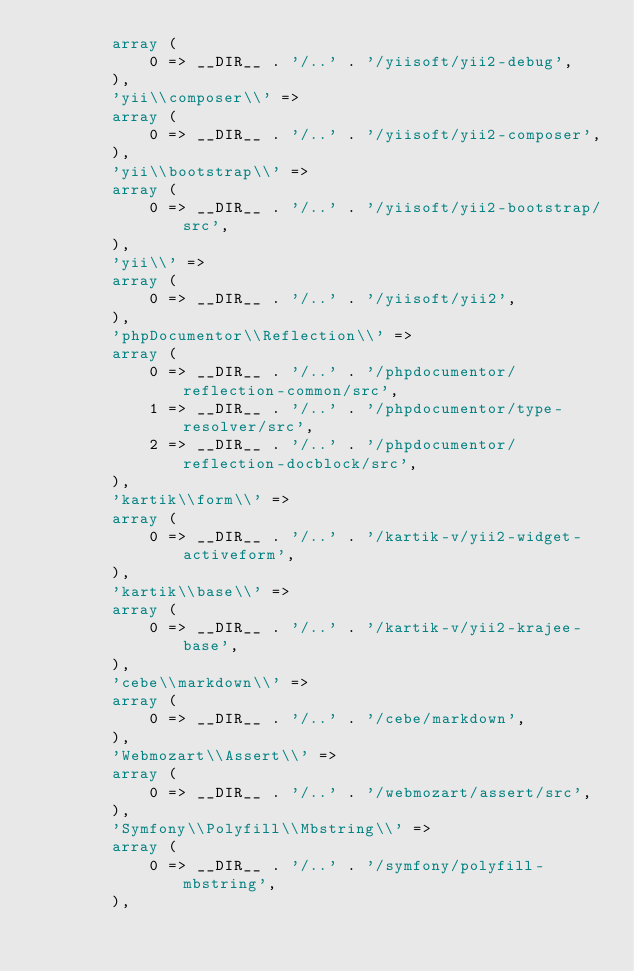<code> <loc_0><loc_0><loc_500><loc_500><_PHP_>        array (
            0 => __DIR__ . '/..' . '/yiisoft/yii2-debug',
        ),
        'yii\\composer\\' => 
        array (
            0 => __DIR__ . '/..' . '/yiisoft/yii2-composer',
        ),
        'yii\\bootstrap\\' => 
        array (
            0 => __DIR__ . '/..' . '/yiisoft/yii2-bootstrap/src',
        ),
        'yii\\' => 
        array (
            0 => __DIR__ . '/..' . '/yiisoft/yii2',
        ),
        'phpDocumentor\\Reflection\\' => 
        array (
            0 => __DIR__ . '/..' . '/phpdocumentor/reflection-common/src',
            1 => __DIR__ . '/..' . '/phpdocumentor/type-resolver/src',
            2 => __DIR__ . '/..' . '/phpdocumentor/reflection-docblock/src',
        ),
        'kartik\\form\\' => 
        array (
            0 => __DIR__ . '/..' . '/kartik-v/yii2-widget-activeform',
        ),
        'kartik\\base\\' => 
        array (
            0 => __DIR__ . '/..' . '/kartik-v/yii2-krajee-base',
        ),
        'cebe\\markdown\\' => 
        array (
            0 => __DIR__ . '/..' . '/cebe/markdown',
        ),
        'Webmozart\\Assert\\' => 
        array (
            0 => __DIR__ . '/..' . '/webmozart/assert/src',
        ),
        'Symfony\\Polyfill\\Mbstring\\' => 
        array (
            0 => __DIR__ . '/..' . '/symfony/polyfill-mbstring',
        ),</code> 